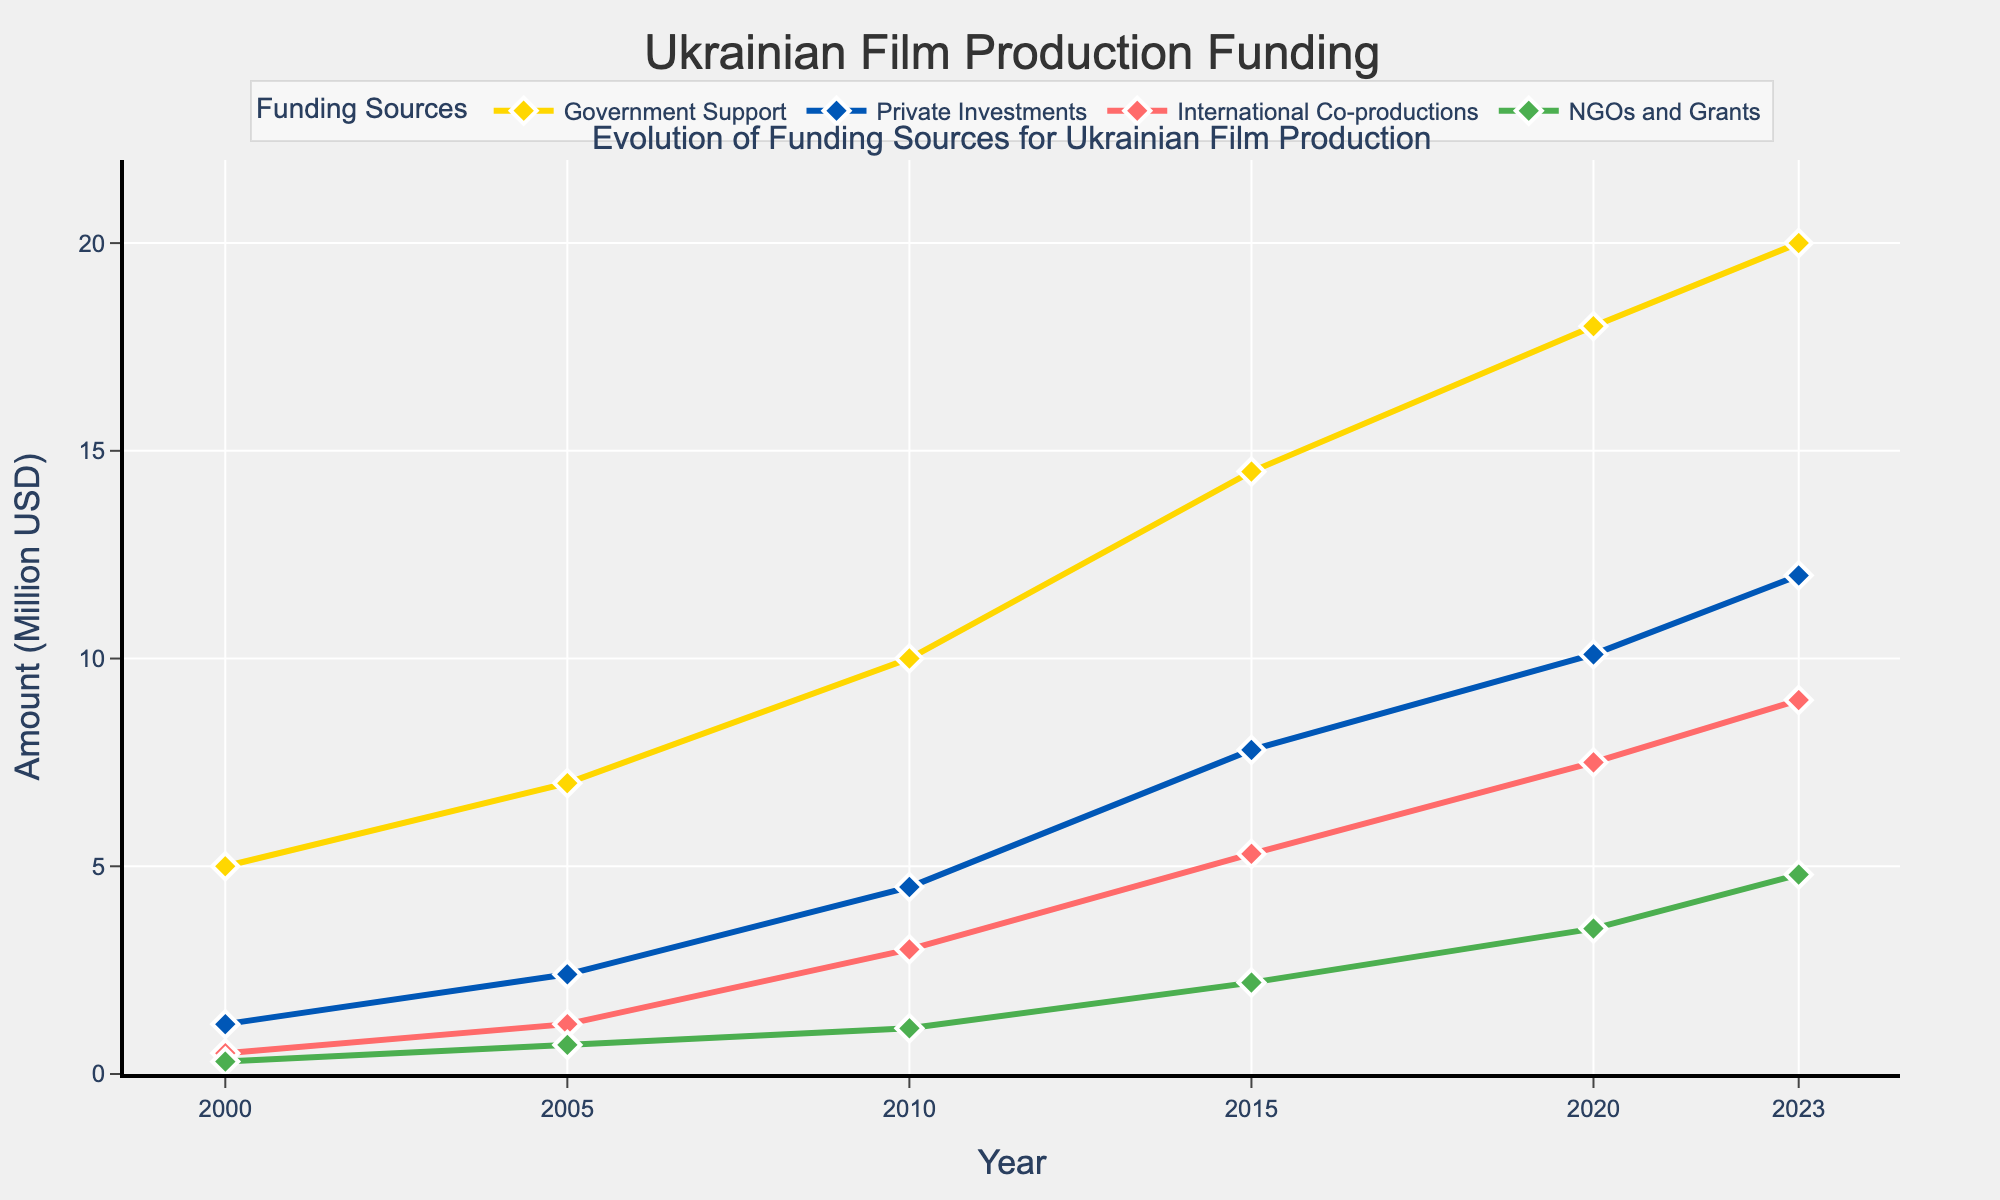How much was the funding from Government Support in 2023? Look at the 2023 data point for Government Support, which shows an amount of 20.0 million USD.
Answer: 20 million USD Which funding source saw the greatest increase from 2000 to 2023? Compare the 2000 and 2023 values for each funding source: Government Support increased from 5.0 to 20.0 million USD, Private Investments increased from 1.2 to 12.0 million USD, International Co-productions increased from 0.5 to 9.0 million USD, and NGOs and Grants increased from 0.3 to 4.8 million USD. Private Investments had the biggest increase of 10.8 million USD.
Answer: Private Investments What is the overall trend in funding from International Co-productions from 2000 to 2023? Observe the data points for International Co-productions, which show a steady increase from 0.5 million USD in 2000 to 9.0 million USD in 2023.
Answer: Increasing trend In which year did NGO and Grants first surpass 1 million USD? Review the values for each year and note that in 2010, NGOs and Grants crossed the 1 million USD mark for the first time with a value of 1.1 million USD.
Answer: 2010 How does the amount of funding from Private Investments in 2010 compare to that in 2005? Check the data points for 2005 and 2010. Private Investments were 2.4 million USD in 2005 and 4.5 million USD in 2010. The increase is 4.5 - 2.4 = 2.1 million USD.
Answer: It increased by 2.1 million USD What is the difference in funding from Government Support between 2015 and 2023? Look at the figures for Government Support in 2015 and 2023: 14.5 million USD in 2015 and 20.0 million USD in 2023. The difference is 20.0 - 14.5 = 5.5 million USD.
Answer: 5.5 million USD Which funding source had the smallest amount in 2000? Compare the amounts from each funding source in the year 2000. NGOs and Grants had the smallest amount, which was 0.3 million USD.
Answer: NGOs and Grants What was the average funding amount from Private Investments from 2000 to 2023? Find the values for Private Investments for each year: 1.2, 2.4, 4.5, 7.8, 10.1, and 12.0. Sum them up: 1.2 + 2.4 + 4.5 + 7.8 + 10.1 + 12.0 = 38.0 million USD. There are 6 data points, so divide by 6: 38.0 / 6 ≈ 6.33 million USD.
Answer: 6.33 million USD 